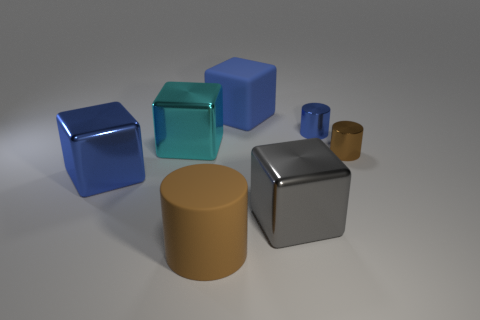Subtract all small blue metal cylinders. How many cylinders are left? 2 Add 2 small cyan matte blocks. How many objects exist? 9 Subtract all red cubes. Subtract all yellow cylinders. How many cubes are left? 4 Subtract all blocks. How many objects are left? 3 Add 6 large metallic cubes. How many large metallic cubes exist? 9 Subtract 0 blue balls. How many objects are left? 7 Subtract all shiny objects. Subtract all large cylinders. How many objects are left? 1 Add 4 matte cylinders. How many matte cylinders are left? 5 